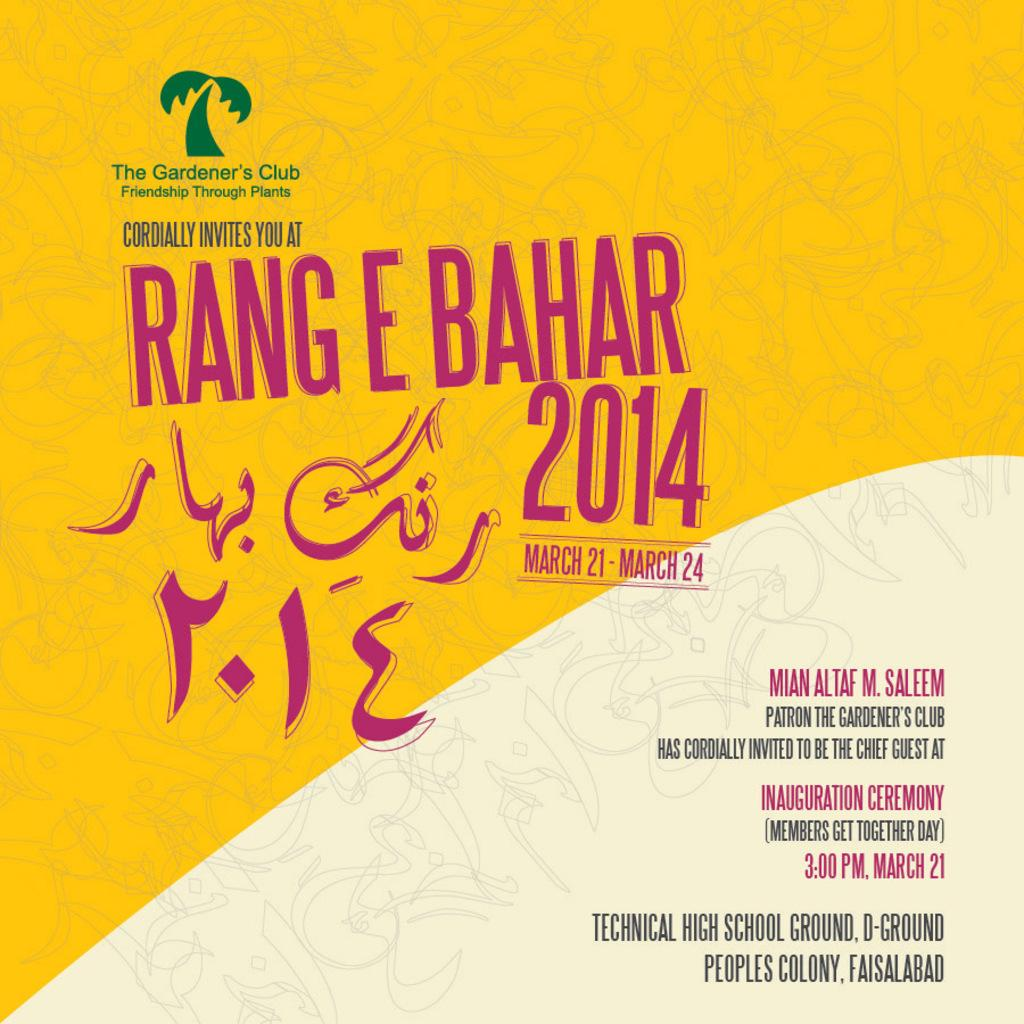Provide a one-sentence caption for the provided image. A yellow poster advertises Rang E Bahar 2014. 